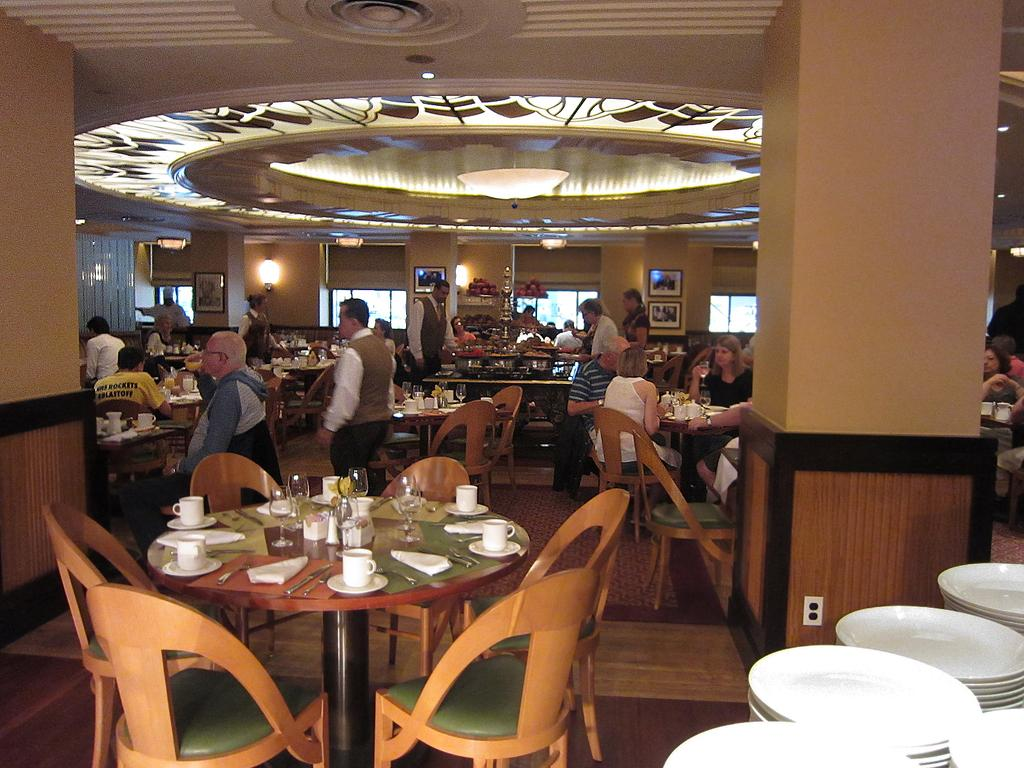What is one of the main features of the image? There is a wall in the image. What can be seen on the wall? There is a light in the image. Who or what is present in the image? There are people in the image. What type of furniture is visible in the image? There are chairs and tables in the image. What items are on the table in the image? On the table, there is a cup, a saucer, a knife, a fork, spoons, and glasses. What type of advertisement is displayed on the wall in the image? There is no advertisement displayed on the wall in the image. What is the condition of the fire in the image? There is no fire present in the image. 